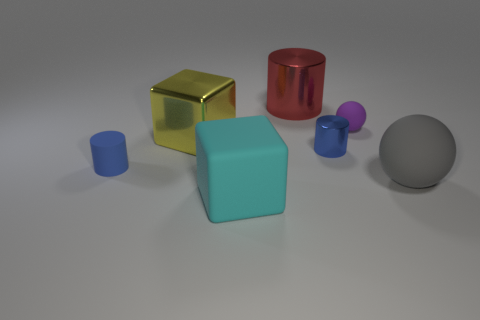Is there anything else that is the same color as the matte cylinder?
Ensure brevity in your answer.  Yes. What shape is the object that is the same color as the small metallic cylinder?
Ensure brevity in your answer.  Cylinder. There is a small matte cylinder; is its color the same as the metallic cylinder that is in front of the yellow shiny thing?
Make the answer very short. Yes. Are the purple ball and the large cube behind the large ball made of the same material?
Offer a very short reply. No. There is a small shiny thing; is it the same shape as the cyan matte thing that is to the right of the small matte cylinder?
Your response must be concise. No. What color is the object that is in front of the tiny blue rubber cylinder and right of the red metallic cylinder?
Your answer should be very brief. Gray. The blue thing that is left of the cylinder behind the blue cylinder to the right of the rubber cylinder is made of what material?
Your answer should be very brief. Rubber. What material is the large sphere?
Your answer should be compact. Rubber. There is another metallic object that is the same shape as the small blue shiny thing; what is its size?
Your answer should be very brief. Large. Is the small matte ball the same color as the small matte cylinder?
Keep it short and to the point. No. 